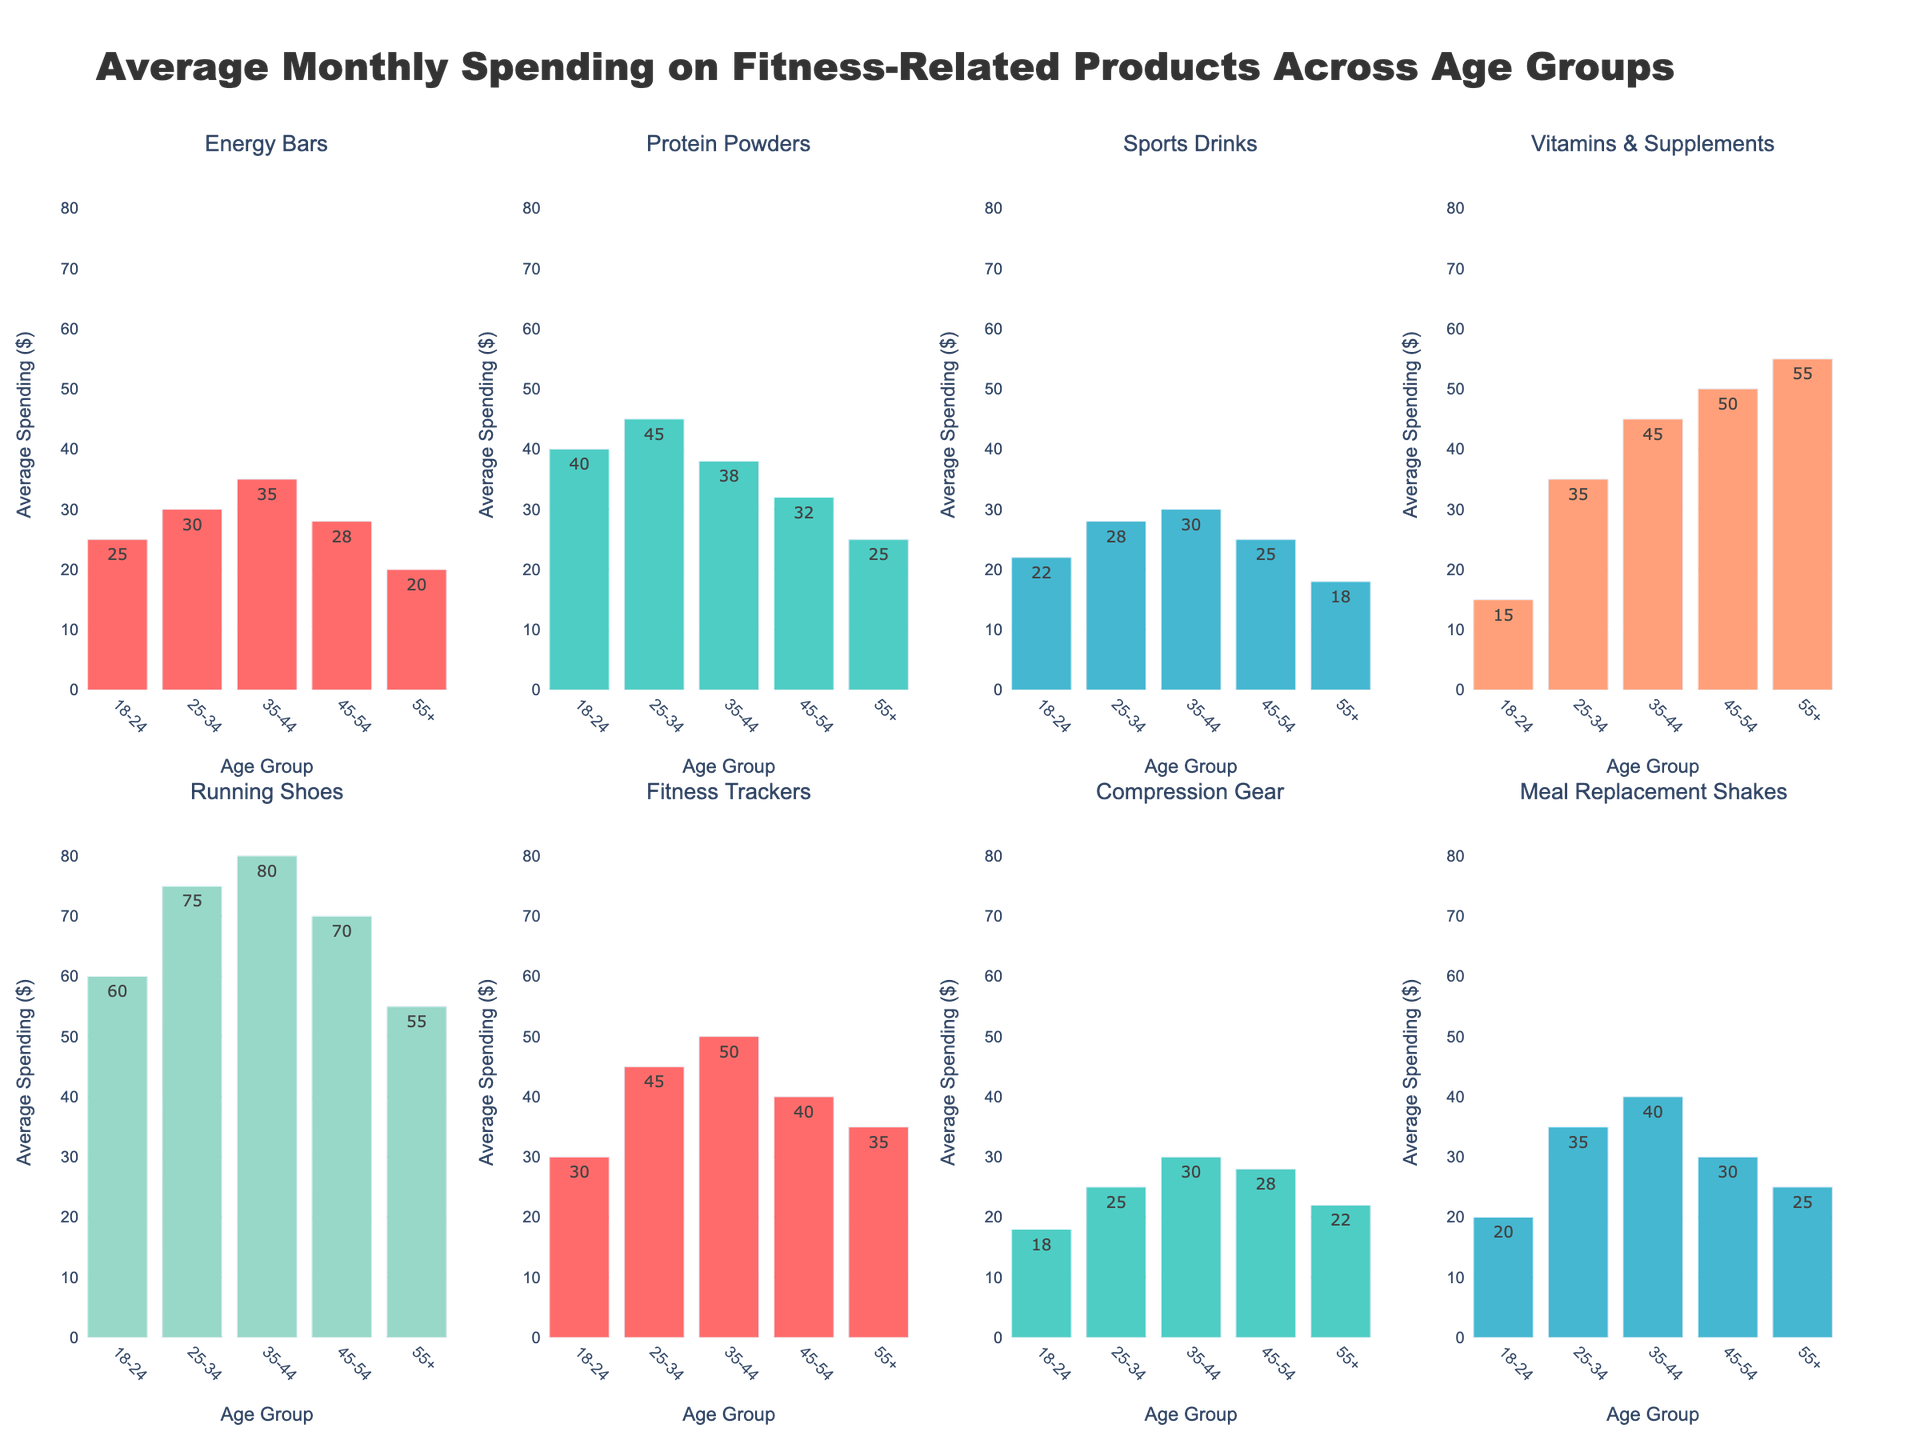What's the title of the chart? The chart title is located at the top center of the figure. It reads "Average Monthly Spending on Fitness-Related Products Across Age Groups".
Answer: Average Monthly Spending on Fitness-Related Products Across Age Groups Which age group spends the most on Running Shoes? To find this, look at the subplot for Running Shoes and identify the bar with the highest value. The age group 35-44 has the highest bar for Running Shoes.
Answer: 35-44 What is the average spending on Protein Powders for the age groups 25-34 and 35-44? Sum the values for Protein Powders for the age groups 25-34 (45) and 35-44 (38), then divide by 2. The calculation is (45 + 38)/2 = 41.5.
Answer: 41.5 How much more do age groups 18-24 spend on Fitness Trackers compared to Vitamins & Supplements? Identify the values for each category for the age group 18-24. For Fitness Trackers, it's 30, and for Vitamins & Supplements, it's 15. Subtract these values: 30 - 15 = 15.
Answer: 15 Which product category sees the highest spending increase from the 18-24 age group to the 25-34 age group? Compare the spending values between the 18-24 and 25-34 age groups for all categories. The highest increase is in Vitamins & Supplements, from 15 (18-24) to 35 (25-34), an increase of 20.
Answer: Vitamins & Supplements Is there any category where the 55+ age group spends more than the 25-34 age group? Compare the spending values for all categories between the 55+ and 25-34 age groups. The 55+ age group spends more only on Vitamins & Supplements (55 vs. 35).
Answer: Yes, Vitamins & Supplements What is the total spending on Energy Bars across all age groups? Sum the values of Energy Bars across all age groups: 25 (18-24) + 30 (25-34) + 35 (35-44) + 28 (45-54) + 20 (55+). The total is 138.
Answer: 138 Which age group has the least average monthly spending on Sports Drinks and Compression Gear combined? Calculate the sum of Sports Drinks and Compression Gear for each age group and identify the smallest total. For the 55+ age group, it’s 18 (Sports Drinks) + 22 (Compression Gear) = 40, which is the lowest total.
Answer: 55+ What is the difference in spending on Meal Replacement Shakes between the 35-44 and 18-24 age groups? Subtract the value for the 18-24 age group (20) from the value for the 35-44 age group (40). The difference is 40 - 20 = 20.
Answer: 20 